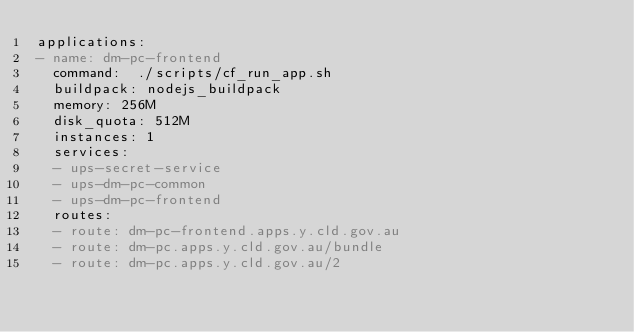<code> <loc_0><loc_0><loc_500><loc_500><_YAML_>applications:
- name: dm-pc-frontend
  command:  ./scripts/cf_run_app.sh
  buildpack: nodejs_buildpack
  memory: 256M
  disk_quota: 512M
  instances: 1
  services:
  - ups-secret-service
  - ups-dm-pc-common
  - ups-dm-pc-frontend
  routes:
  - route: dm-pc-frontend.apps.y.cld.gov.au
  - route: dm-pc.apps.y.cld.gov.au/bundle
  - route: dm-pc.apps.y.cld.gov.au/2</code> 